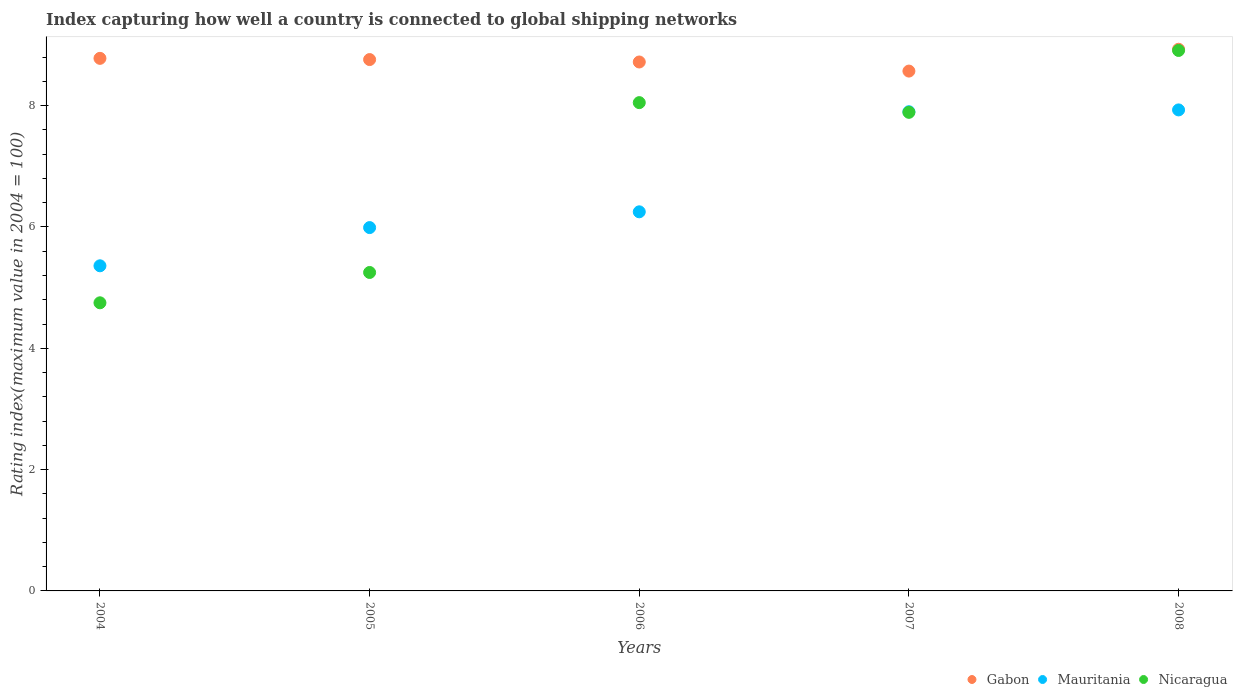How many different coloured dotlines are there?
Ensure brevity in your answer.  3. Is the number of dotlines equal to the number of legend labels?
Keep it short and to the point. Yes. Across all years, what is the maximum rating index in Nicaragua?
Offer a terse response. 8.91. Across all years, what is the minimum rating index in Mauritania?
Provide a succinct answer. 5.36. In which year was the rating index in Gabon maximum?
Your answer should be compact. 2008. What is the total rating index in Mauritania in the graph?
Make the answer very short. 33.43. What is the difference between the rating index in Gabon in 2004 and that in 2007?
Your response must be concise. 0.21. What is the difference between the rating index in Gabon in 2005 and the rating index in Nicaragua in 2008?
Your response must be concise. -0.15. What is the average rating index in Gabon per year?
Your answer should be compact. 8.75. In the year 2005, what is the difference between the rating index in Nicaragua and rating index in Gabon?
Provide a short and direct response. -3.51. In how many years, is the rating index in Mauritania greater than 4.8?
Your response must be concise. 5. What is the ratio of the rating index in Mauritania in 2004 to that in 2008?
Keep it short and to the point. 0.68. Is the rating index in Nicaragua in 2007 less than that in 2008?
Your answer should be compact. Yes. What is the difference between the highest and the second highest rating index in Mauritania?
Offer a terse response. 0.03. What is the difference between the highest and the lowest rating index in Mauritania?
Your answer should be compact. 2.57. Is the sum of the rating index in Gabon in 2004 and 2007 greater than the maximum rating index in Nicaragua across all years?
Your response must be concise. Yes. Is it the case that in every year, the sum of the rating index in Mauritania and rating index in Gabon  is greater than the rating index in Nicaragua?
Make the answer very short. Yes. Is the rating index in Gabon strictly greater than the rating index in Mauritania over the years?
Keep it short and to the point. Yes. How many years are there in the graph?
Ensure brevity in your answer.  5. Does the graph contain grids?
Your answer should be compact. No. Where does the legend appear in the graph?
Offer a very short reply. Bottom right. How many legend labels are there?
Make the answer very short. 3. How are the legend labels stacked?
Your response must be concise. Horizontal. What is the title of the graph?
Ensure brevity in your answer.  Index capturing how well a country is connected to global shipping networks. Does "Cote d'Ivoire" appear as one of the legend labels in the graph?
Ensure brevity in your answer.  No. What is the label or title of the X-axis?
Your answer should be very brief. Years. What is the label or title of the Y-axis?
Offer a terse response. Rating index(maximum value in 2004 = 100). What is the Rating index(maximum value in 2004 = 100) of Gabon in 2004?
Offer a very short reply. 8.78. What is the Rating index(maximum value in 2004 = 100) of Mauritania in 2004?
Ensure brevity in your answer.  5.36. What is the Rating index(maximum value in 2004 = 100) in Nicaragua in 2004?
Your response must be concise. 4.75. What is the Rating index(maximum value in 2004 = 100) in Gabon in 2005?
Ensure brevity in your answer.  8.76. What is the Rating index(maximum value in 2004 = 100) in Mauritania in 2005?
Provide a short and direct response. 5.99. What is the Rating index(maximum value in 2004 = 100) of Nicaragua in 2005?
Make the answer very short. 5.25. What is the Rating index(maximum value in 2004 = 100) in Gabon in 2006?
Give a very brief answer. 8.72. What is the Rating index(maximum value in 2004 = 100) of Mauritania in 2006?
Provide a succinct answer. 6.25. What is the Rating index(maximum value in 2004 = 100) of Nicaragua in 2006?
Your answer should be very brief. 8.05. What is the Rating index(maximum value in 2004 = 100) in Gabon in 2007?
Your answer should be compact. 8.57. What is the Rating index(maximum value in 2004 = 100) of Nicaragua in 2007?
Your answer should be very brief. 7.89. What is the Rating index(maximum value in 2004 = 100) of Gabon in 2008?
Make the answer very short. 8.93. What is the Rating index(maximum value in 2004 = 100) of Mauritania in 2008?
Offer a terse response. 7.93. What is the Rating index(maximum value in 2004 = 100) in Nicaragua in 2008?
Offer a terse response. 8.91. Across all years, what is the maximum Rating index(maximum value in 2004 = 100) in Gabon?
Offer a very short reply. 8.93. Across all years, what is the maximum Rating index(maximum value in 2004 = 100) in Mauritania?
Keep it short and to the point. 7.93. Across all years, what is the maximum Rating index(maximum value in 2004 = 100) of Nicaragua?
Your answer should be very brief. 8.91. Across all years, what is the minimum Rating index(maximum value in 2004 = 100) of Gabon?
Provide a succinct answer. 8.57. Across all years, what is the minimum Rating index(maximum value in 2004 = 100) in Mauritania?
Your answer should be compact. 5.36. Across all years, what is the minimum Rating index(maximum value in 2004 = 100) in Nicaragua?
Keep it short and to the point. 4.75. What is the total Rating index(maximum value in 2004 = 100) of Gabon in the graph?
Provide a succinct answer. 43.76. What is the total Rating index(maximum value in 2004 = 100) of Mauritania in the graph?
Offer a terse response. 33.43. What is the total Rating index(maximum value in 2004 = 100) of Nicaragua in the graph?
Offer a very short reply. 34.85. What is the difference between the Rating index(maximum value in 2004 = 100) of Mauritania in 2004 and that in 2005?
Ensure brevity in your answer.  -0.63. What is the difference between the Rating index(maximum value in 2004 = 100) in Nicaragua in 2004 and that in 2005?
Keep it short and to the point. -0.5. What is the difference between the Rating index(maximum value in 2004 = 100) of Mauritania in 2004 and that in 2006?
Make the answer very short. -0.89. What is the difference between the Rating index(maximum value in 2004 = 100) in Gabon in 2004 and that in 2007?
Make the answer very short. 0.21. What is the difference between the Rating index(maximum value in 2004 = 100) in Mauritania in 2004 and that in 2007?
Offer a terse response. -2.54. What is the difference between the Rating index(maximum value in 2004 = 100) of Nicaragua in 2004 and that in 2007?
Ensure brevity in your answer.  -3.14. What is the difference between the Rating index(maximum value in 2004 = 100) of Gabon in 2004 and that in 2008?
Offer a very short reply. -0.15. What is the difference between the Rating index(maximum value in 2004 = 100) in Mauritania in 2004 and that in 2008?
Make the answer very short. -2.57. What is the difference between the Rating index(maximum value in 2004 = 100) of Nicaragua in 2004 and that in 2008?
Offer a very short reply. -4.16. What is the difference between the Rating index(maximum value in 2004 = 100) in Mauritania in 2005 and that in 2006?
Provide a succinct answer. -0.26. What is the difference between the Rating index(maximum value in 2004 = 100) in Nicaragua in 2005 and that in 2006?
Ensure brevity in your answer.  -2.8. What is the difference between the Rating index(maximum value in 2004 = 100) in Gabon in 2005 and that in 2007?
Your answer should be compact. 0.19. What is the difference between the Rating index(maximum value in 2004 = 100) of Mauritania in 2005 and that in 2007?
Offer a terse response. -1.91. What is the difference between the Rating index(maximum value in 2004 = 100) in Nicaragua in 2005 and that in 2007?
Offer a terse response. -2.64. What is the difference between the Rating index(maximum value in 2004 = 100) in Gabon in 2005 and that in 2008?
Your answer should be very brief. -0.17. What is the difference between the Rating index(maximum value in 2004 = 100) of Mauritania in 2005 and that in 2008?
Give a very brief answer. -1.94. What is the difference between the Rating index(maximum value in 2004 = 100) in Nicaragua in 2005 and that in 2008?
Ensure brevity in your answer.  -3.66. What is the difference between the Rating index(maximum value in 2004 = 100) of Mauritania in 2006 and that in 2007?
Give a very brief answer. -1.65. What is the difference between the Rating index(maximum value in 2004 = 100) of Nicaragua in 2006 and that in 2007?
Ensure brevity in your answer.  0.16. What is the difference between the Rating index(maximum value in 2004 = 100) in Gabon in 2006 and that in 2008?
Provide a short and direct response. -0.21. What is the difference between the Rating index(maximum value in 2004 = 100) in Mauritania in 2006 and that in 2008?
Your response must be concise. -1.68. What is the difference between the Rating index(maximum value in 2004 = 100) of Nicaragua in 2006 and that in 2008?
Provide a succinct answer. -0.86. What is the difference between the Rating index(maximum value in 2004 = 100) in Gabon in 2007 and that in 2008?
Keep it short and to the point. -0.36. What is the difference between the Rating index(maximum value in 2004 = 100) of Mauritania in 2007 and that in 2008?
Offer a terse response. -0.03. What is the difference between the Rating index(maximum value in 2004 = 100) of Nicaragua in 2007 and that in 2008?
Provide a succinct answer. -1.02. What is the difference between the Rating index(maximum value in 2004 = 100) of Gabon in 2004 and the Rating index(maximum value in 2004 = 100) of Mauritania in 2005?
Give a very brief answer. 2.79. What is the difference between the Rating index(maximum value in 2004 = 100) in Gabon in 2004 and the Rating index(maximum value in 2004 = 100) in Nicaragua in 2005?
Ensure brevity in your answer.  3.53. What is the difference between the Rating index(maximum value in 2004 = 100) in Mauritania in 2004 and the Rating index(maximum value in 2004 = 100) in Nicaragua in 2005?
Your answer should be very brief. 0.11. What is the difference between the Rating index(maximum value in 2004 = 100) in Gabon in 2004 and the Rating index(maximum value in 2004 = 100) in Mauritania in 2006?
Your answer should be compact. 2.53. What is the difference between the Rating index(maximum value in 2004 = 100) in Gabon in 2004 and the Rating index(maximum value in 2004 = 100) in Nicaragua in 2006?
Offer a very short reply. 0.73. What is the difference between the Rating index(maximum value in 2004 = 100) in Mauritania in 2004 and the Rating index(maximum value in 2004 = 100) in Nicaragua in 2006?
Offer a terse response. -2.69. What is the difference between the Rating index(maximum value in 2004 = 100) of Gabon in 2004 and the Rating index(maximum value in 2004 = 100) of Nicaragua in 2007?
Keep it short and to the point. 0.89. What is the difference between the Rating index(maximum value in 2004 = 100) in Mauritania in 2004 and the Rating index(maximum value in 2004 = 100) in Nicaragua in 2007?
Keep it short and to the point. -2.53. What is the difference between the Rating index(maximum value in 2004 = 100) in Gabon in 2004 and the Rating index(maximum value in 2004 = 100) in Nicaragua in 2008?
Ensure brevity in your answer.  -0.13. What is the difference between the Rating index(maximum value in 2004 = 100) of Mauritania in 2004 and the Rating index(maximum value in 2004 = 100) of Nicaragua in 2008?
Provide a succinct answer. -3.55. What is the difference between the Rating index(maximum value in 2004 = 100) of Gabon in 2005 and the Rating index(maximum value in 2004 = 100) of Mauritania in 2006?
Make the answer very short. 2.51. What is the difference between the Rating index(maximum value in 2004 = 100) of Gabon in 2005 and the Rating index(maximum value in 2004 = 100) of Nicaragua in 2006?
Offer a very short reply. 0.71. What is the difference between the Rating index(maximum value in 2004 = 100) of Mauritania in 2005 and the Rating index(maximum value in 2004 = 100) of Nicaragua in 2006?
Your response must be concise. -2.06. What is the difference between the Rating index(maximum value in 2004 = 100) in Gabon in 2005 and the Rating index(maximum value in 2004 = 100) in Mauritania in 2007?
Provide a short and direct response. 0.86. What is the difference between the Rating index(maximum value in 2004 = 100) in Gabon in 2005 and the Rating index(maximum value in 2004 = 100) in Nicaragua in 2007?
Your answer should be compact. 0.87. What is the difference between the Rating index(maximum value in 2004 = 100) in Gabon in 2005 and the Rating index(maximum value in 2004 = 100) in Mauritania in 2008?
Provide a succinct answer. 0.83. What is the difference between the Rating index(maximum value in 2004 = 100) in Gabon in 2005 and the Rating index(maximum value in 2004 = 100) in Nicaragua in 2008?
Offer a very short reply. -0.15. What is the difference between the Rating index(maximum value in 2004 = 100) in Mauritania in 2005 and the Rating index(maximum value in 2004 = 100) in Nicaragua in 2008?
Ensure brevity in your answer.  -2.92. What is the difference between the Rating index(maximum value in 2004 = 100) of Gabon in 2006 and the Rating index(maximum value in 2004 = 100) of Mauritania in 2007?
Your answer should be compact. 0.82. What is the difference between the Rating index(maximum value in 2004 = 100) in Gabon in 2006 and the Rating index(maximum value in 2004 = 100) in Nicaragua in 2007?
Provide a short and direct response. 0.83. What is the difference between the Rating index(maximum value in 2004 = 100) of Mauritania in 2006 and the Rating index(maximum value in 2004 = 100) of Nicaragua in 2007?
Keep it short and to the point. -1.64. What is the difference between the Rating index(maximum value in 2004 = 100) of Gabon in 2006 and the Rating index(maximum value in 2004 = 100) of Mauritania in 2008?
Provide a short and direct response. 0.79. What is the difference between the Rating index(maximum value in 2004 = 100) in Gabon in 2006 and the Rating index(maximum value in 2004 = 100) in Nicaragua in 2008?
Your response must be concise. -0.19. What is the difference between the Rating index(maximum value in 2004 = 100) in Mauritania in 2006 and the Rating index(maximum value in 2004 = 100) in Nicaragua in 2008?
Your response must be concise. -2.66. What is the difference between the Rating index(maximum value in 2004 = 100) in Gabon in 2007 and the Rating index(maximum value in 2004 = 100) in Mauritania in 2008?
Provide a succinct answer. 0.64. What is the difference between the Rating index(maximum value in 2004 = 100) of Gabon in 2007 and the Rating index(maximum value in 2004 = 100) of Nicaragua in 2008?
Ensure brevity in your answer.  -0.34. What is the difference between the Rating index(maximum value in 2004 = 100) in Mauritania in 2007 and the Rating index(maximum value in 2004 = 100) in Nicaragua in 2008?
Offer a very short reply. -1.01. What is the average Rating index(maximum value in 2004 = 100) of Gabon per year?
Give a very brief answer. 8.75. What is the average Rating index(maximum value in 2004 = 100) of Mauritania per year?
Your response must be concise. 6.69. What is the average Rating index(maximum value in 2004 = 100) of Nicaragua per year?
Make the answer very short. 6.97. In the year 2004, what is the difference between the Rating index(maximum value in 2004 = 100) of Gabon and Rating index(maximum value in 2004 = 100) of Mauritania?
Your answer should be compact. 3.42. In the year 2004, what is the difference between the Rating index(maximum value in 2004 = 100) of Gabon and Rating index(maximum value in 2004 = 100) of Nicaragua?
Ensure brevity in your answer.  4.03. In the year 2004, what is the difference between the Rating index(maximum value in 2004 = 100) in Mauritania and Rating index(maximum value in 2004 = 100) in Nicaragua?
Provide a short and direct response. 0.61. In the year 2005, what is the difference between the Rating index(maximum value in 2004 = 100) in Gabon and Rating index(maximum value in 2004 = 100) in Mauritania?
Your answer should be compact. 2.77. In the year 2005, what is the difference between the Rating index(maximum value in 2004 = 100) of Gabon and Rating index(maximum value in 2004 = 100) of Nicaragua?
Make the answer very short. 3.51. In the year 2005, what is the difference between the Rating index(maximum value in 2004 = 100) in Mauritania and Rating index(maximum value in 2004 = 100) in Nicaragua?
Provide a short and direct response. 0.74. In the year 2006, what is the difference between the Rating index(maximum value in 2004 = 100) of Gabon and Rating index(maximum value in 2004 = 100) of Mauritania?
Your answer should be very brief. 2.47. In the year 2006, what is the difference between the Rating index(maximum value in 2004 = 100) of Gabon and Rating index(maximum value in 2004 = 100) of Nicaragua?
Your answer should be very brief. 0.67. In the year 2006, what is the difference between the Rating index(maximum value in 2004 = 100) of Mauritania and Rating index(maximum value in 2004 = 100) of Nicaragua?
Your answer should be very brief. -1.8. In the year 2007, what is the difference between the Rating index(maximum value in 2004 = 100) in Gabon and Rating index(maximum value in 2004 = 100) in Mauritania?
Your answer should be compact. 0.67. In the year 2007, what is the difference between the Rating index(maximum value in 2004 = 100) of Gabon and Rating index(maximum value in 2004 = 100) of Nicaragua?
Provide a succinct answer. 0.68. In the year 2008, what is the difference between the Rating index(maximum value in 2004 = 100) of Gabon and Rating index(maximum value in 2004 = 100) of Mauritania?
Provide a succinct answer. 1. In the year 2008, what is the difference between the Rating index(maximum value in 2004 = 100) in Gabon and Rating index(maximum value in 2004 = 100) in Nicaragua?
Your answer should be very brief. 0.02. In the year 2008, what is the difference between the Rating index(maximum value in 2004 = 100) in Mauritania and Rating index(maximum value in 2004 = 100) in Nicaragua?
Make the answer very short. -0.98. What is the ratio of the Rating index(maximum value in 2004 = 100) in Mauritania in 2004 to that in 2005?
Make the answer very short. 0.89. What is the ratio of the Rating index(maximum value in 2004 = 100) in Nicaragua in 2004 to that in 2005?
Offer a terse response. 0.9. What is the ratio of the Rating index(maximum value in 2004 = 100) of Gabon in 2004 to that in 2006?
Provide a succinct answer. 1.01. What is the ratio of the Rating index(maximum value in 2004 = 100) of Mauritania in 2004 to that in 2006?
Keep it short and to the point. 0.86. What is the ratio of the Rating index(maximum value in 2004 = 100) in Nicaragua in 2004 to that in 2006?
Keep it short and to the point. 0.59. What is the ratio of the Rating index(maximum value in 2004 = 100) in Gabon in 2004 to that in 2007?
Offer a very short reply. 1.02. What is the ratio of the Rating index(maximum value in 2004 = 100) of Mauritania in 2004 to that in 2007?
Ensure brevity in your answer.  0.68. What is the ratio of the Rating index(maximum value in 2004 = 100) in Nicaragua in 2004 to that in 2007?
Provide a succinct answer. 0.6. What is the ratio of the Rating index(maximum value in 2004 = 100) of Gabon in 2004 to that in 2008?
Your response must be concise. 0.98. What is the ratio of the Rating index(maximum value in 2004 = 100) in Mauritania in 2004 to that in 2008?
Provide a succinct answer. 0.68. What is the ratio of the Rating index(maximum value in 2004 = 100) in Nicaragua in 2004 to that in 2008?
Offer a very short reply. 0.53. What is the ratio of the Rating index(maximum value in 2004 = 100) of Mauritania in 2005 to that in 2006?
Ensure brevity in your answer.  0.96. What is the ratio of the Rating index(maximum value in 2004 = 100) in Nicaragua in 2005 to that in 2006?
Your response must be concise. 0.65. What is the ratio of the Rating index(maximum value in 2004 = 100) of Gabon in 2005 to that in 2007?
Give a very brief answer. 1.02. What is the ratio of the Rating index(maximum value in 2004 = 100) in Mauritania in 2005 to that in 2007?
Keep it short and to the point. 0.76. What is the ratio of the Rating index(maximum value in 2004 = 100) in Nicaragua in 2005 to that in 2007?
Give a very brief answer. 0.67. What is the ratio of the Rating index(maximum value in 2004 = 100) in Mauritania in 2005 to that in 2008?
Keep it short and to the point. 0.76. What is the ratio of the Rating index(maximum value in 2004 = 100) in Nicaragua in 2005 to that in 2008?
Your answer should be compact. 0.59. What is the ratio of the Rating index(maximum value in 2004 = 100) in Gabon in 2006 to that in 2007?
Make the answer very short. 1.02. What is the ratio of the Rating index(maximum value in 2004 = 100) of Mauritania in 2006 to that in 2007?
Ensure brevity in your answer.  0.79. What is the ratio of the Rating index(maximum value in 2004 = 100) in Nicaragua in 2006 to that in 2007?
Offer a terse response. 1.02. What is the ratio of the Rating index(maximum value in 2004 = 100) of Gabon in 2006 to that in 2008?
Provide a short and direct response. 0.98. What is the ratio of the Rating index(maximum value in 2004 = 100) of Mauritania in 2006 to that in 2008?
Offer a terse response. 0.79. What is the ratio of the Rating index(maximum value in 2004 = 100) in Nicaragua in 2006 to that in 2008?
Make the answer very short. 0.9. What is the ratio of the Rating index(maximum value in 2004 = 100) of Gabon in 2007 to that in 2008?
Make the answer very short. 0.96. What is the ratio of the Rating index(maximum value in 2004 = 100) in Nicaragua in 2007 to that in 2008?
Offer a terse response. 0.89. What is the difference between the highest and the second highest Rating index(maximum value in 2004 = 100) in Gabon?
Offer a very short reply. 0.15. What is the difference between the highest and the second highest Rating index(maximum value in 2004 = 100) in Nicaragua?
Keep it short and to the point. 0.86. What is the difference between the highest and the lowest Rating index(maximum value in 2004 = 100) in Gabon?
Your answer should be compact. 0.36. What is the difference between the highest and the lowest Rating index(maximum value in 2004 = 100) of Mauritania?
Your answer should be very brief. 2.57. What is the difference between the highest and the lowest Rating index(maximum value in 2004 = 100) of Nicaragua?
Your response must be concise. 4.16. 